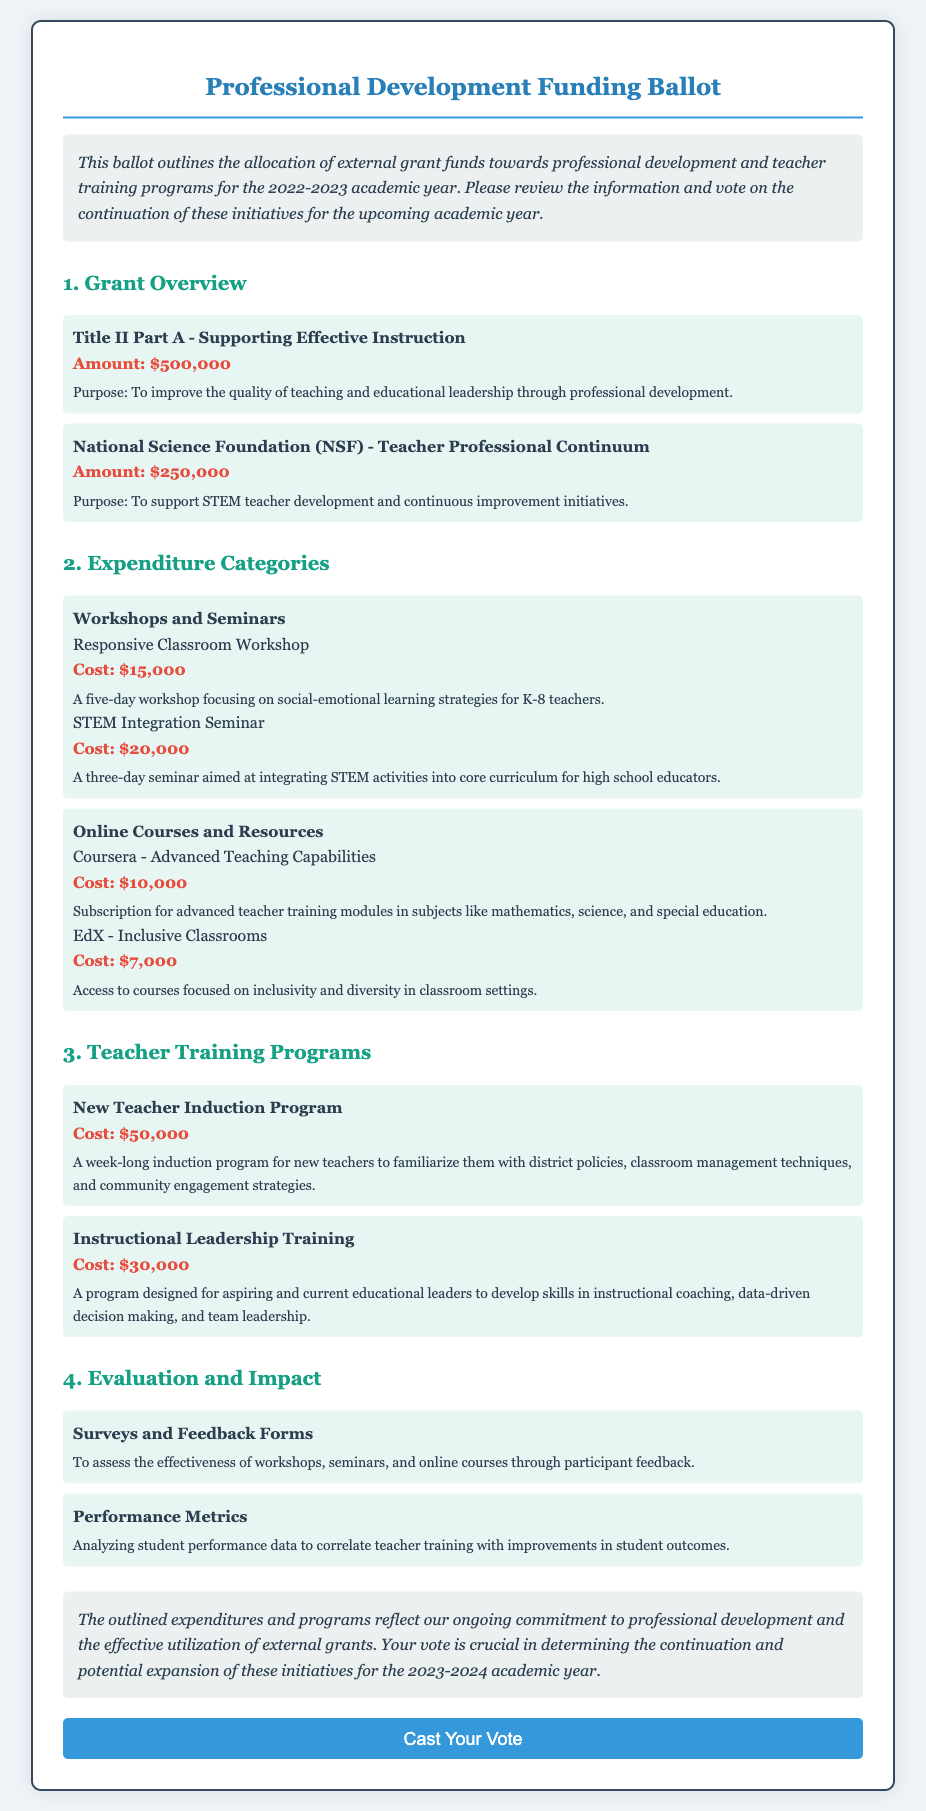What is the total amount of the Title II Part A grant? The Title II Part A grant amount is specifically mentioned in the document as $500,000.
Answer: $500,000 How much is allocated for the STEM Integration Seminar? The document states that the cost for the STEM Integration Seminar is $20,000.
Answer: $20,000 What is the purpose of the National Science Foundation grant? The document provides that the purpose is to support STEM teacher development and continuous improvement initiatives.
Answer: Support STEM teacher development What is the total cost of the New Teacher Induction Program? The document lists the cost of the New Teacher Induction Program as $50,000.
Answer: $50,000 Which evaluation method analyzes student performance data? The document indicates that the evaluation method analyzing student performance data is referred to as Performance Metrics.
Answer: Performance Metrics How many events are listed under Workshops and Seminars? There are two events specified in the document under the Workshops and Seminars category.
Answer: Two What is the cost of the EdX - Inclusive Classrooms course? The document states that the cost of the EdX - Inclusive Classrooms course is $7,000.
Answer: $7,000 What type of feedback is collected to assess the effectiveness of programs? The document states that Surveys and Feedback Forms are used to collect feedback for assessment.
Answer: Surveys and Feedback Forms What is the total funding amount from the National Science Foundation grant? The document specifies that the National Science Foundation grant amount is $250,000.
Answer: $250,000 